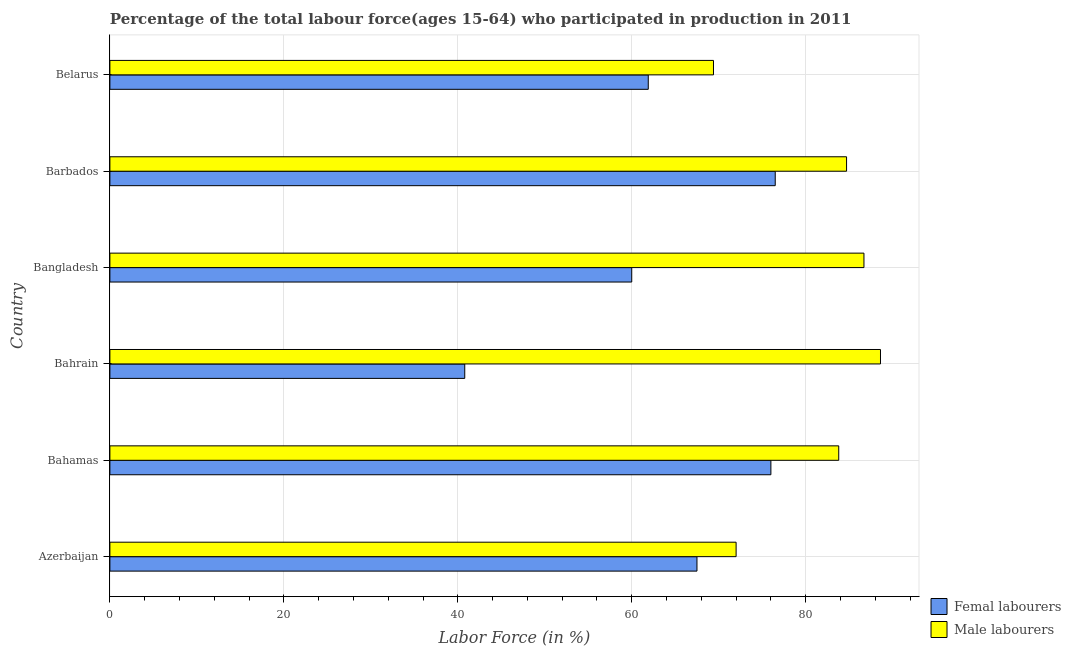How many different coloured bars are there?
Give a very brief answer. 2. How many groups of bars are there?
Ensure brevity in your answer.  6. Are the number of bars per tick equal to the number of legend labels?
Your answer should be compact. Yes. What is the label of the 5th group of bars from the top?
Ensure brevity in your answer.  Bahamas. What is the percentage of male labour force in Bahamas?
Your response must be concise. 83.8. Across all countries, what is the maximum percentage of male labour force?
Your answer should be compact. 88.6. Across all countries, what is the minimum percentage of female labor force?
Provide a short and direct response. 40.8. In which country was the percentage of male labour force maximum?
Provide a short and direct response. Bahrain. In which country was the percentage of female labor force minimum?
Offer a very short reply. Bahrain. What is the total percentage of female labor force in the graph?
Your answer should be very brief. 382.7. What is the difference between the percentage of male labour force in Bangladesh and that in Belarus?
Keep it short and to the point. 17.3. What is the difference between the percentage of female labor force in Bahrain and the percentage of male labour force in Bahamas?
Your answer should be very brief. -43. What is the average percentage of female labor force per country?
Offer a very short reply. 63.78. In how many countries, is the percentage of male labour force greater than 24 %?
Your response must be concise. 6. Is the percentage of female labor force in Azerbaijan less than that in Barbados?
Your response must be concise. Yes. What is the difference between the highest and the second highest percentage of female labor force?
Keep it short and to the point. 0.5. In how many countries, is the percentage of male labour force greater than the average percentage of male labour force taken over all countries?
Ensure brevity in your answer.  4. What does the 1st bar from the top in Bahamas represents?
Provide a short and direct response. Male labourers. What does the 1st bar from the bottom in Bahamas represents?
Keep it short and to the point. Femal labourers. How many bars are there?
Your answer should be compact. 12. Are all the bars in the graph horizontal?
Make the answer very short. Yes. How many countries are there in the graph?
Keep it short and to the point. 6. Does the graph contain grids?
Give a very brief answer. Yes. How are the legend labels stacked?
Provide a short and direct response. Vertical. What is the title of the graph?
Offer a terse response. Percentage of the total labour force(ages 15-64) who participated in production in 2011. Does "Services" appear as one of the legend labels in the graph?
Provide a succinct answer. No. What is the Labor Force (in %) of Femal labourers in Azerbaijan?
Make the answer very short. 67.5. What is the Labor Force (in %) of Femal labourers in Bahamas?
Give a very brief answer. 76. What is the Labor Force (in %) of Male labourers in Bahamas?
Provide a succinct answer. 83.8. What is the Labor Force (in %) of Femal labourers in Bahrain?
Make the answer very short. 40.8. What is the Labor Force (in %) in Male labourers in Bahrain?
Ensure brevity in your answer.  88.6. What is the Labor Force (in %) in Femal labourers in Bangladesh?
Provide a short and direct response. 60. What is the Labor Force (in %) of Male labourers in Bangladesh?
Give a very brief answer. 86.7. What is the Labor Force (in %) in Femal labourers in Barbados?
Provide a short and direct response. 76.5. What is the Labor Force (in %) of Male labourers in Barbados?
Your answer should be very brief. 84.7. What is the Labor Force (in %) of Femal labourers in Belarus?
Make the answer very short. 61.9. What is the Labor Force (in %) in Male labourers in Belarus?
Offer a terse response. 69.4. Across all countries, what is the maximum Labor Force (in %) in Femal labourers?
Offer a terse response. 76.5. Across all countries, what is the maximum Labor Force (in %) in Male labourers?
Provide a short and direct response. 88.6. Across all countries, what is the minimum Labor Force (in %) of Femal labourers?
Your response must be concise. 40.8. Across all countries, what is the minimum Labor Force (in %) of Male labourers?
Provide a succinct answer. 69.4. What is the total Labor Force (in %) of Femal labourers in the graph?
Ensure brevity in your answer.  382.7. What is the total Labor Force (in %) in Male labourers in the graph?
Your answer should be compact. 485.2. What is the difference between the Labor Force (in %) of Femal labourers in Azerbaijan and that in Bahamas?
Your response must be concise. -8.5. What is the difference between the Labor Force (in %) in Femal labourers in Azerbaijan and that in Bahrain?
Keep it short and to the point. 26.7. What is the difference between the Labor Force (in %) in Male labourers in Azerbaijan and that in Bahrain?
Ensure brevity in your answer.  -16.6. What is the difference between the Labor Force (in %) in Male labourers in Azerbaijan and that in Bangladesh?
Make the answer very short. -14.7. What is the difference between the Labor Force (in %) of Femal labourers in Azerbaijan and that in Belarus?
Ensure brevity in your answer.  5.6. What is the difference between the Labor Force (in %) in Femal labourers in Bahamas and that in Bahrain?
Provide a succinct answer. 35.2. What is the difference between the Labor Force (in %) of Male labourers in Bahamas and that in Bahrain?
Make the answer very short. -4.8. What is the difference between the Labor Force (in %) in Femal labourers in Bahamas and that in Bangladesh?
Offer a very short reply. 16. What is the difference between the Labor Force (in %) of Male labourers in Bahamas and that in Barbados?
Keep it short and to the point. -0.9. What is the difference between the Labor Force (in %) of Femal labourers in Bahrain and that in Bangladesh?
Ensure brevity in your answer.  -19.2. What is the difference between the Labor Force (in %) in Male labourers in Bahrain and that in Bangladesh?
Offer a very short reply. 1.9. What is the difference between the Labor Force (in %) of Femal labourers in Bahrain and that in Barbados?
Keep it short and to the point. -35.7. What is the difference between the Labor Force (in %) in Femal labourers in Bahrain and that in Belarus?
Offer a very short reply. -21.1. What is the difference between the Labor Force (in %) in Male labourers in Bahrain and that in Belarus?
Provide a succinct answer. 19.2. What is the difference between the Labor Force (in %) in Femal labourers in Bangladesh and that in Barbados?
Offer a terse response. -16.5. What is the difference between the Labor Force (in %) of Male labourers in Bangladesh and that in Barbados?
Your answer should be compact. 2. What is the difference between the Labor Force (in %) of Male labourers in Barbados and that in Belarus?
Your response must be concise. 15.3. What is the difference between the Labor Force (in %) of Femal labourers in Azerbaijan and the Labor Force (in %) of Male labourers in Bahamas?
Give a very brief answer. -16.3. What is the difference between the Labor Force (in %) in Femal labourers in Azerbaijan and the Labor Force (in %) in Male labourers in Bahrain?
Your response must be concise. -21.1. What is the difference between the Labor Force (in %) in Femal labourers in Azerbaijan and the Labor Force (in %) in Male labourers in Bangladesh?
Offer a terse response. -19.2. What is the difference between the Labor Force (in %) in Femal labourers in Azerbaijan and the Labor Force (in %) in Male labourers in Barbados?
Make the answer very short. -17.2. What is the difference between the Labor Force (in %) in Femal labourers in Azerbaijan and the Labor Force (in %) in Male labourers in Belarus?
Provide a succinct answer. -1.9. What is the difference between the Labor Force (in %) of Femal labourers in Bahamas and the Labor Force (in %) of Male labourers in Bahrain?
Provide a succinct answer. -12.6. What is the difference between the Labor Force (in %) of Femal labourers in Bahamas and the Labor Force (in %) of Male labourers in Bangladesh?
Make the answer very short. -10.7. What is the difference between the Labor Force (in %) in Femal labourers in Bahamas and the Labor Force (in %) in Male labourers in Barbados?
Your answer should be compact. -8.7. What is the difference between the Labor Force (in %) of Femal labourers in Bahamas and the Labor Force (in %) of Male labourers in Belarus?
Offer a very short reply. 6.6. What is the difference between the Labor Force (in %) in Femal labourers in Bahrain and the Labor Force (in %) in Male labourers in Bangladesh?
Give a very brief answer. -45.9. What is the difference between the Labor Force (in %) in Femal labourers in Bahrain and the Labor Force (in %) in Male labourers in Barbados?
Offer a very short reply. -43.9. What is the difference between the Labor Force (in %) in Femal labourers in Bahrain and the Labor Force (in %) in Male labourers in Belarus?
Offer a terse response. -28.6. What is the difference between the Labor Force (in %) in Femal labourers in Bangladesh and the Labor Force (in %) in Male labourers in Barbados?
Make the answer very short. -24.7. What is the difference between the Labor Force (in %) in Femal labourers in Bangladesh and the Labor Force (in %) in Male labourers in Belarus?
Ensure brevity in your answer.  -9.4. What is the average Labor Force (in %) of Femal labourers per country?
Offer a very short reply. 63.78. What is the average Labor Force (in %) of Male labourers per country?
Offer a terse response. 80.87. What is the difference between the Labor Force (in %) of Femal labourers and Labor Force (in %) of Male labourers in Azerbaijan?
Provide a short and direct response. -4.5. What is the difference between the Labor Force (in %) in Femal labourers and Labor Force (in %) in Male labourers in Bahamas?
Offer a terse response. -7.8. What is the difference between the Labor Force (in %) in Femal labourers and Labor Force (in %) in Male labourers in Bahrain?
Offer a very short reply. -47.8. What is the difference between the Labor Force (in %) of Femal labourers and Labor Force (in %) of Male labourers in Bangladesh?
Make the answer very short. -26.7. What is the ratio of the Labor Force (in %) of Femal labourers in Azerbaijan to that in Bahamas?
Your answer should be compact. 0.89. What is the ratio of the Labor Force (in %) in Male labourers in Azerbaijan to that in Bahamas?
Your response must be concise. 0.86. What is the ratio of the Labor Force (in %) of Femal labourers in Azerbaijan to that in Bahrain?
Provide a succinct answer. 1.65. What is the ratio of the Labor Force (in %) in Male labourers in Azerbaijan to that in Bahrain?
Give a very brief answer. 0.81. What is the ratio of the Labor Force (in %) in Femal labourers in Azerbaijan to that in Bangladesh?
Offer a very short reply. 1.12. What is the ratio of the Labor Force (in %) in Male labourers in Azerbaijan to that in Bangladesh?
Give a very brief answer. 0.83. What is the ratio of the Labor Force (in %) of Femal labourers in Azerbaijan to that in Barbados?
Offer a terse response. 0.88. What is the ratio of the Labor Force (in %) of Male labourers in Azerbaijan to that in Barbados?
Your response must be concise. 0.85. What is the ratio of the Labor Force (in %) in Femal labourers in Azerbaijan to that in Belarus?
Your answer should be very brief. 1.09. What is the ratio of the Labor Force (in %) of Male labourers in Azerbaijan to that in Belarus?
Your answer should be compact. 1.04. What is the ratio of the Labor Force (in %) in Femal labourers in Bahamas to that in Bahrain?
Offer a terse response. 1.86. What is the ratio of the Labor Force (in %) of Male labourers in Bahamas to that in Bahrain?
Provide a succinct answer. 0.95. What is the ratio of the Labor Force (in %) in Femal labourers in Bahamas to that in Bangladesh?
Offer a terse response. 1.27. What is the ratio of the Labor Force (in %) in Male labourers in Bahamas to that in Bangladesh?
Ensure brevity in your answer.  0.97. What is the ratio of the Labor Force (in %) in Male labourers in Bahamas to that in Barbados?
Make the answer very short. 0.99. What is the ratio of the Labor Force (in %) of Femal labourers in Bahamas to that in Belarus?
Make the answer very short. 1.23. What is the ratio of the Labor Force (in %) in Male labourers in Bahamas to that in Belarus?
Your answer should be very brief. 1.21. What is the ratio of the Labor Force (in %) in Femal labourers in Bahrain to that in Bangladesh?
Your answer should be compact. 0.68. What is the ratio of the Labor Force (in %) of Male labourers in Bahrain to that in Bangladesh?
Make the answer very short. 1.02. What is the ratio of the Labor Force (in %) in Femal labourers in Bahrain to that in Barbados?
Give a very brief answer. 0.53. What is the ratio of the Labor Force (in %) in Male labourers in Bahrain to that in Barbados?
Provide a short and direct response. 1.05. What is the ratio of the Labor Force (in %) of Femal labourers in Bahrain to that in Belarus?
Your answer should be very brief. 0.66. What is the ratio of the Labor Force (in %) of Male labourers in Bahrain to that in Belarus?
Offer a very short reply. 1.28. What is the ratio of the Labor Force (in %) in Femal labourers in Bangladesh to that in Barbados?
Offer a very short reply. 0.78. What is the ratio of the Labor Force (in %) of Male labourers in Bangladesh to that in Barbados?
Your response must be concise. 1.02. What is the ratio of the Labor Force (in %) in Femal labourers in Bangladesh to that in Belarus?
Give a very brief answer. 0.97. What is the ratio of the Labor Force (in %) of Male labourers in Bangladesh to that in Belarus?
Your answer should be compact. 1.25. What is the ratio of the Labor Force (in %) in Femal labourers in Barbados to that in Belarus?
Make the answer very short. 1.24. What is the ratio of the Labor Force (in %) of Male labourers in Barbados to that in Belarus?
Provide a short and direct response. 1.22. What is the difference between the highest and the second highest Labor Force (in %) in Femal labourers?
Your response must be concise. 0.5. What is the difference between the highest and the second highest Labor Force (in %) in Male labourers?
Your response must be concise. 1.9. What is the difference between the highest and the lowest Labor Force (in %) of Femal labourers?
Provide a succinct answer. 35.7. 